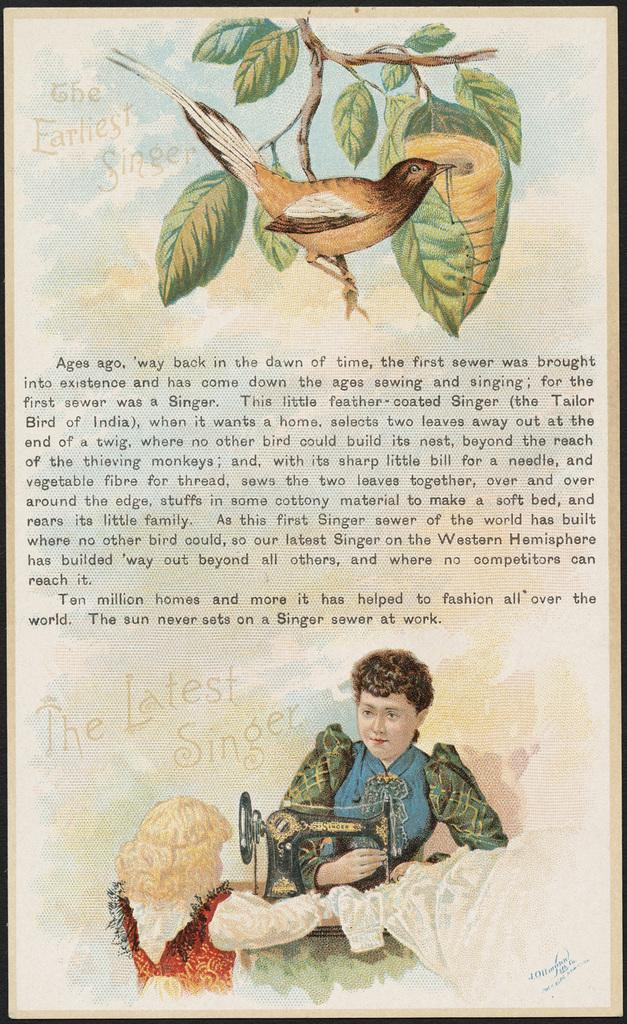What type of artwork is depicted in the image? The image is a painting. What natural elements can be seen in the painting? There are leaves and branches in the painting. Are there any human figures in the painting? Yes, there are people in the painting. What man-made object is present in the painting? There is a sewing machine in the painting. Can you describe the bird in the painting? There is a bird on a branch in the painting. What additional information is conveyed in the painting? There is some information present in the painting. How far away is the pet from the table in the painting? There is no pet or table present in the painting; it features a bird on a branch and a sewing machine. 